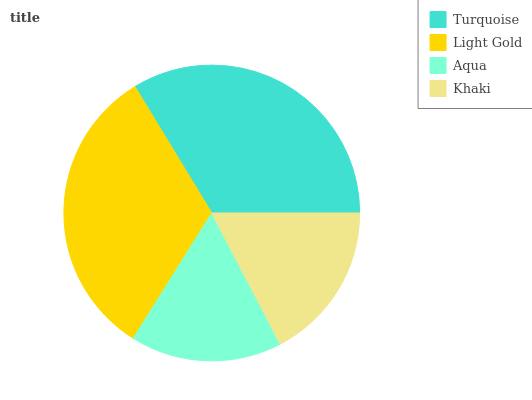Is Aqua the minimum?
Answer yes or no. Yes. Is Turquoise the maximum?
Answer yes or no. Yes. Is Light Gold the minimum?
Answer yes or no. No. Is Light Gold the maximum?
Answer yes or no. No. Is Turquoise greater than Light Gold?
Answer yes or no. Yes. Is Light Gold less than Turquoise?
Answer yes or no. Yes. Is Light Gold greater than Turquoise?
Answer yes or no. No. Is Turquoise less than Light Gold?
Answer yes or no. No. Is Light Gold the high median?
Answer yes or no. Yes. Is Khaki the low median?
Answer yes or no. Yes. Is Aqua the high median?
Answer yes or no. No. Is Turquoise the low median?
Answer yes or no. No. 